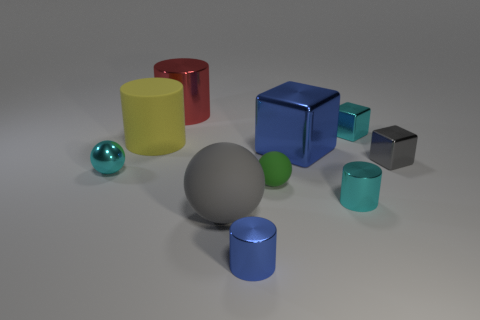What color is the other large thing that is the same shape as the large red thing?
Your answer should be very brief. Yellow. How many things are small balls or cylinders behind the blue metallic cylinder?
Ensure brevity in your answer.  5. Are there fewer large shiny blocks behind the large blue shiny cube than small yellow matte cubes?
Your answer should be compact. No. There is a shiny cube that is behind the blue metallic thing that is behind the shiny thing right of the cyan cube; what is its size?
Keep it short and to the point. Small. The shiny cylinder that is left of the tiny green rubber thing and in front of the large yellow cylinder is what color?
Your response must be concise. Blue. How many gray balls are there?
Give a very brief answer. 1. Does the gray ball have the same material as the green sphere?
Provide a succinct answer. Yes. Does the block that is in front of the big shiny block have the same size as the matte ball to the right of the blue cylinder?
Keep it short and to the point. Yes. Are there fewer tiny blue metallic cylinders than small cyan objects?
Provide a succinct answer. Yes. How many matte objects are either big cylinders or large spheres?
Offer a very short reply. 2. 